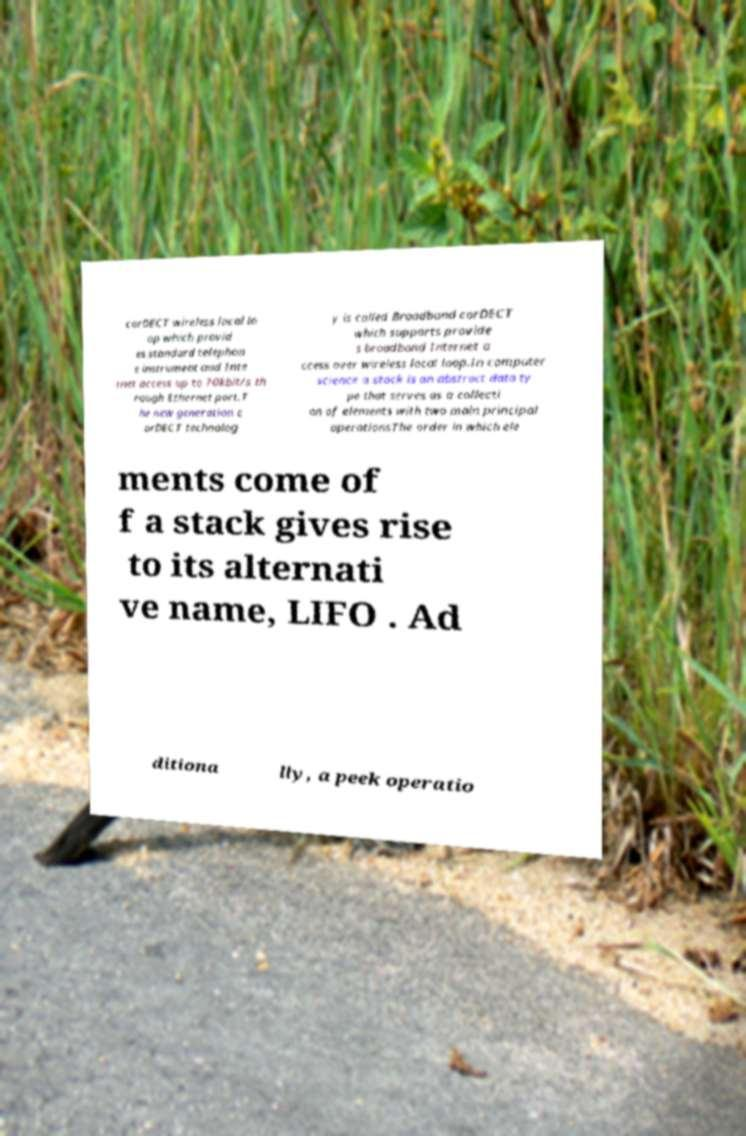What messages or text are displayed in this image? I need them in a readable, typed format. corDECT wireless local lo op which provid es standard telephon e instrument and Inte rnet access up to 70kbit/s th rough Ethernet port.T he new generation c orDECT technolog y is called Broadband corDECT which supports provide s broadband Internet a ccess over wireless local loop.In computer science a stack is an abstract data ty pe that serves as a collecti on of elements with two main principal operationsThe order in which ele ments come of f a stack gives rise to its alternati ve name, LIFO . Ad ditiona lly, a peek operatio 